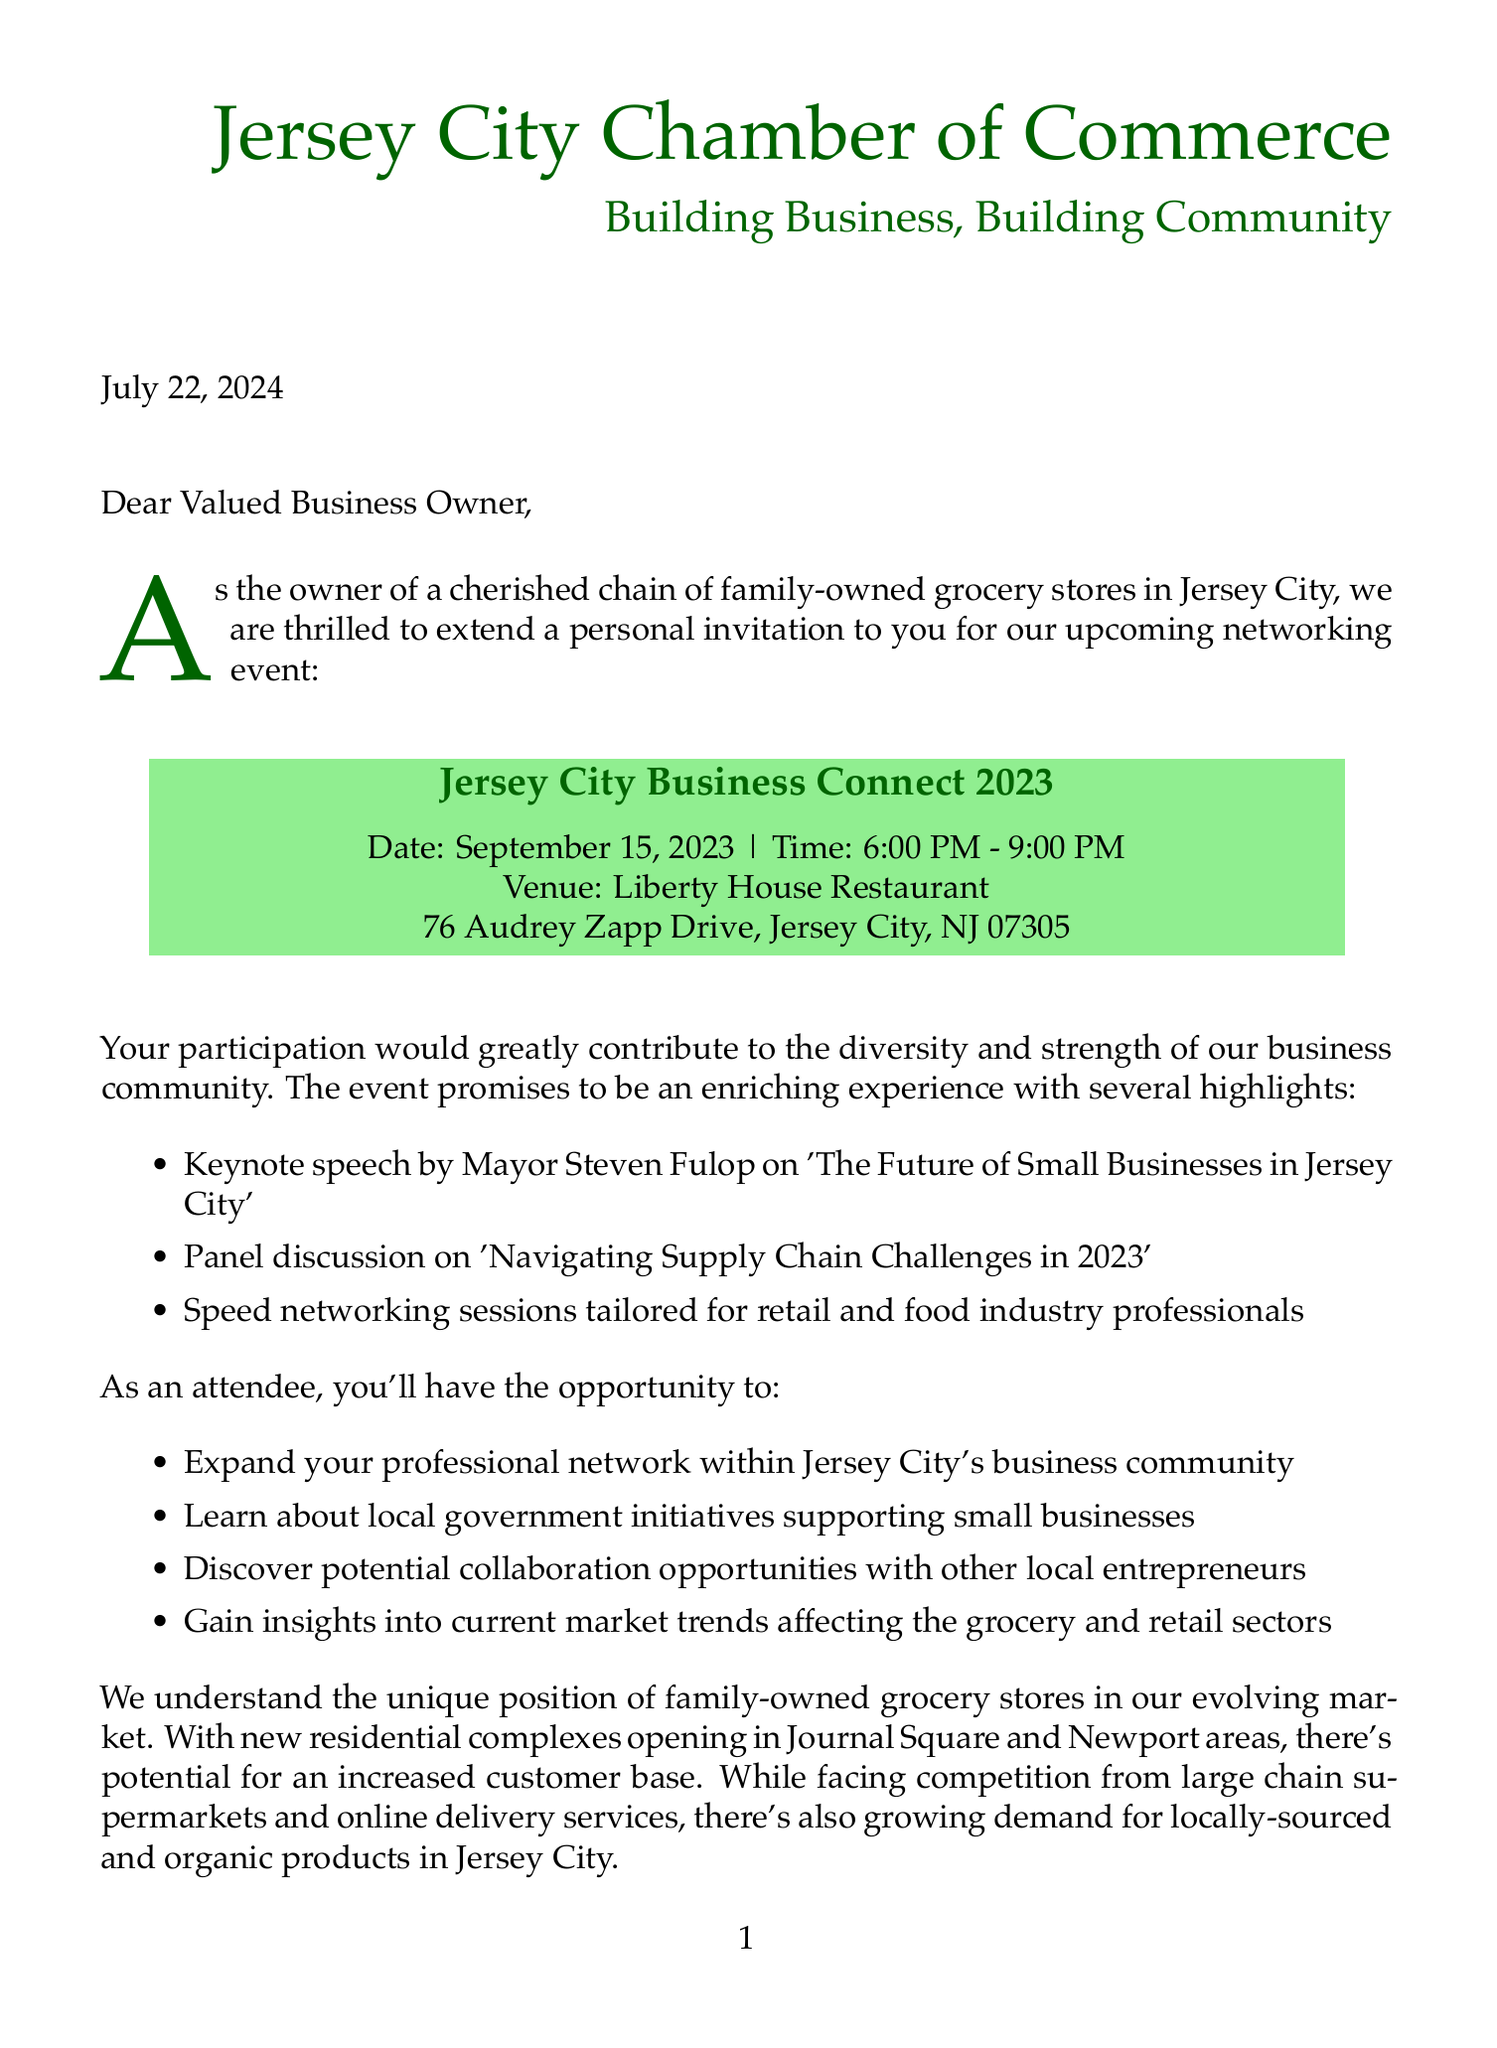What is the event name? The event name is mentioned clearly in the document as part of the invitation details.
Answer: Jersey City Business Connect 2023 What date is the event scheduled? The date of the event is explicitly stated in the document under event details.
Answer: September 15, 2023 Who is the president of the Jersey City Chamber of Commerce? The document lists the name of the president in the chamber information section.
Answer: Maria Nieves What is the RSVP deadline? The deadline for RSVPs is stated towards the end of the document.
Answer: September 1, 2023 What is the ticket price for Chamber members? The document provides specific pricing information under RSVP details.
Answer: $50 What is one highlighted topic of the panel discussion? The document specifies topics covered during the event in the highlighted section.
Answer: Navigating Supply Chain Challenges in 2023 What insights can attendees gain regarding market trends? Attendees can learn about market trends as mentioned in the benefits section of the document.
Answer: Current market trends affecting the grocery and retail sectors What type of businesses is the event particularly aimed at? The letter mentions specific industries that would benefit from the networking event.
Answer: Retail and food industry professionals What segment is mentioned for family-owned businesses? The document explicitly refers to a segment tailored for family-owned businesses.
Answer: Success Stories: Family-Owned Businesses in Jersey City 